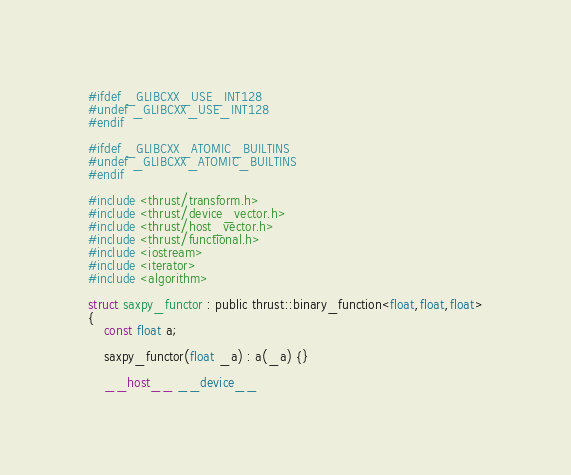<code> <loc_0><loc_0><loc_500><loc_500><_Cuda_>#ifdef _GLIBCXX_USE_INT128
#undef _GLIBCXX_USE_INT128
#endif 

#ifdef _GLIBCXX_ATOMIC_BUILTINS
#undef _GLIBCXX_ATOMIC_BUILTINS
#endif

#include <thrust/transform.h>
#include <thrust/device_vector.h>
#include <thrust/host_vector.h>
#include <thrust/functional.h>
#include <iostream>
#include <iterator>
#include <algorithm>

struct saxpy_functor : public thrust::binary_function<float,float,float>
{
    const float a;

    saxpy_functor(float _a) : a(_a) {}

    __host__ __device__</code> 